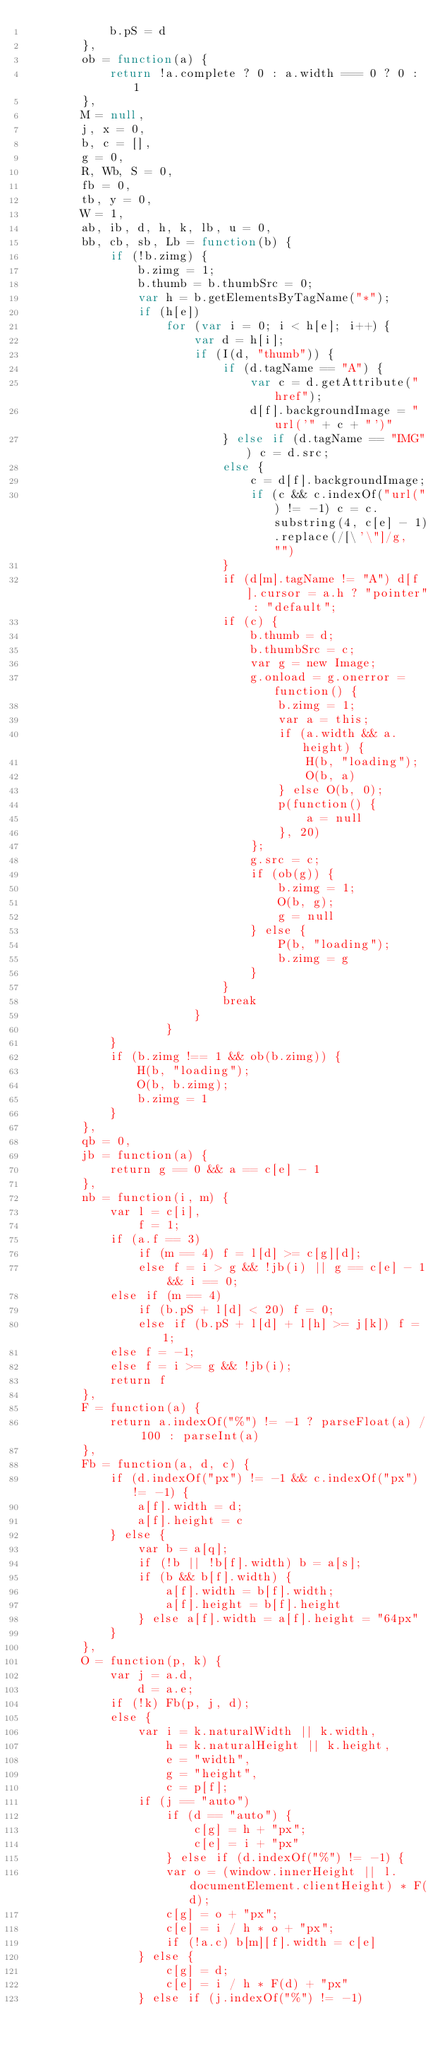Convert code to text. <code><loc_0><loc_0><loc_500><loc_500><_JavaScript_>            b.pS = d
        },
        ob = function(a) {
            return !a.complete ? 0 : a.width === 0 ? 0 : 1
        },
        M = null,
        j, x = 0,
        b, c = [],
        g = 0,
        R, Wb, S = 0,
        fb = 0,
        tb, y = 0,
        W = 1,
        ab, ib, d, h, k, lb, u = 0,
        bb, cb, sb, Lb = function(b) {
            if (!b.zimg) {
                b.zimg = 1;
                b.thumb = b.thumbSrc = 0;
                var h = b.getElementsByTagName("*");
                if (h[e])
                    for (var i = 0; i < h[e]; i++) {
                        var d = h[i];
                        if (I(d, "thumb")) {
                            if (d.tagName == "A") {
                                var c = d.getAttribute("href");
                                d[f].backgroundImage = "url('" + c + "')"
                            } else if (d.tagName == "IMG") c = d.src;
                            else {
                                c = d[f].backgroundImage;
                                if (c && c.indexOf("url(") != -1) c = c.substring(4, c[e] - 1).replace(/[\'\"]/g, "")
                            }
                            if (d[m].tagName != "A") d[f].cursor = a.h ? "pointer" : "default";
                            if (c) {
                                b.thumb = d;
                                b.thumbSrc = c;
                                var g = new Image;
                                g.onload = g.onerror = function() {
                                    b.zimg = 1;
                                    var a = this;
                                    if (a.width && a.height) {
                                        H(b, "loading");
                                        O(b, a)
                                    } else O(b, 0);
                                    p(function() {
                                        a = null
                                    }, 20)
                                };
                                g.src = c;
                                if (ob(g)) {
                                    b.zimg = 1;
                                    O(b, g);
                                    g = null
                                } else {
                                    P(b, "loading");
                                    b.zimg = g
                                }
                            }
                            break
                        }
                    }
            }
            if (b.zimg !== 1 && ob(b.zimg)) {
                H(b, "loading");
                O(b, b.zimg);
                b.zimg = 1
            }
        },
        qb = 0,
        jb = function(a) {
            return g == 0 && a == c[e] - 1
        },
        nb = function(i, m) {
            var l = c[i],
                f = 1;
            if (a.f == 3)
                if (m == 4) f = l[d] >= c[g][d];
                else f = i > g && !jb(i) || g == c[e] - 1 && i == 0;
            else if (m == 4)
                if (b.pS + l[d] < 20) f = 0;
                else if (b.pS + l[d] + l[h] >= j[k]) f = 1;
            else f = -1;
            else f = i >= g && !jb(i);
            return f
        },
        F = function(a) {
            return a.indexOf("%") != -1 ? parseFloat(a) / 100 : parseInt(a)
        },
        Fb = function(a, d, c) {
            if (d.indexOf("px") != -1 && c.indexOf("px") != -1) {
                a[f].width = d;
                a[f].height = c
            } else {
                var b = a[q];
                if (!b || !b[f].width) b = a[s];
                if (b && b[f].width) {
                    a[f].width = b[f].width;
                    a[f].height = b[f].height
                } else a[f].width = a[f].height = "64px"
            }
        },
        O = function(p, k) {
            var j = a.d,
                d = a.e;
            if (!k) Fb(p, j, d);
            else {
                var i = k.naturalWidth || k.width,
                    h = k.naturalHeight || k.height,
                    e = "width",
                    g = "height",
                    c = p[f];
                if (j == "auto")
                    if (d == "auto") {
                        c[g] = h + "px";
                        c[e] = i + "px"
                    } else if (d.indexOf("%") != -1) {
                    var o = (window.innerHeight || l.documentElement.clientHeight) * F(d);
                    c[g] = o + "px";
                    c[e] = i / h * o + "px";
                    if (!a.c) b[m][f].width = c[e]
                } else {
                    c[g] = d;
                    c[e] = i / h * F(d) + "px"
                } else if (j.indexOf("%") != -1)</code> 